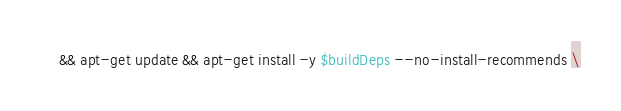Convert code to text. <code><loc_0><loc_0><loc_500><loc_500><_Dockerfile_>	&& apt-get update && apt-get install -y $buildDeps --no-install-recommends \</code> 